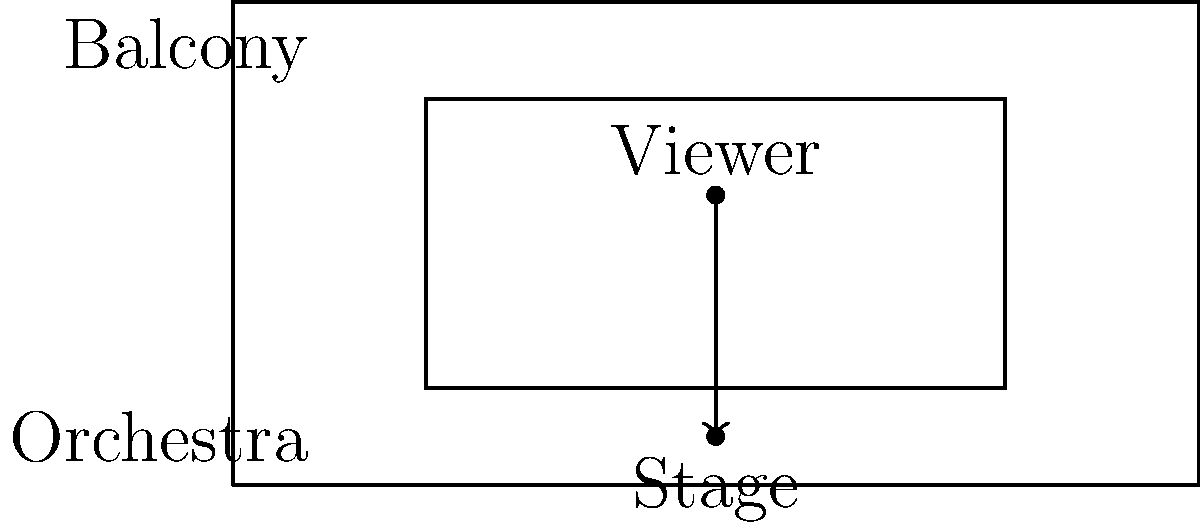In a Broadway theater, considering the sight lines from different seating areas, which factor most significantly affects the visibility of the stage for a viewer seated in the balcony compared to one in the orchestra section? To determine the factor that most significantly affects the visibility of the stage for a viewer in the balcony compared to one in the orchestra section, we need to consider several aspects:

1. Vertical angle: 
   - Balcony viewers have a steeper downward angle to the stage.
   - Orchestra viewers have a more horizontal or slightly upward angle.

2. Distance:
   - Balcony viewers are typically farther from the stage.
   - Orchestra viewers are generally closer to the stage.

3. Obstructions:
   - Balcony viewers may have railings or other viewers in their line of sight.
   - Orchestra viewers might have heads of other audience members obstructing their view.

4. Elevation:
   - Balcony viewers are at a higher elevation, looking down on the stage.
   - Orchestra viewers are at a lower elevation, looking up at the stage.

The most significant factor in this comparison is the vertical angle of view. This angle affects how much of the stage depth can be seen and how well the performers' faces and expressions are visible.

Balcony viewers have a steeper downward angle, which allows them to see more of the stage floor and the overall blocking of the performance. However, this angle can make it harder to see performers' faces clearly, especially when they are facing the orchestra section.

Orchestra viewers have a more horizontal or slightly upward angle, which may limit their view of the stage floor but provides a better view of performers' faces and expressions when they are facing forward.

This vertical angle difference is inherent to the theater design and cannot be easily changed, unlike factors such as distance (which can be mitigated by using binoculars) or obstructions (which can be addressed by careful seat selection or theater design).
Answer: Vertical angle of view 